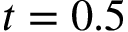<formula> <loc_0><loc_0><loc_500><loc_500>t = 0 . 5</formula> 